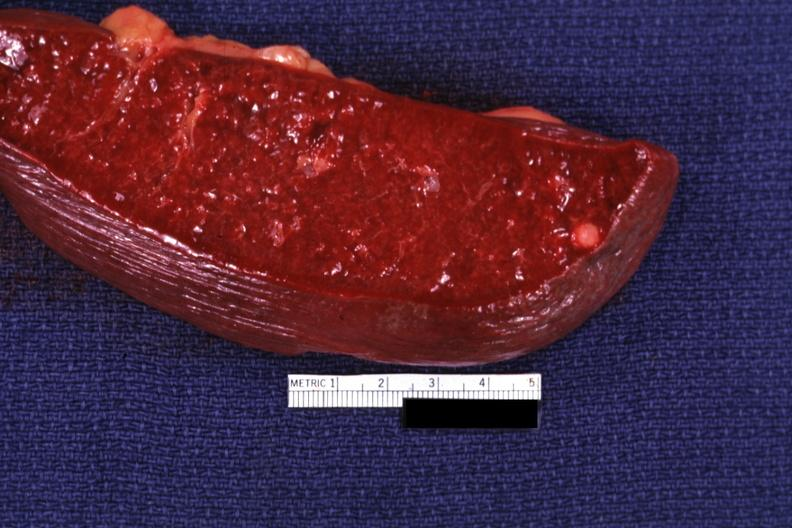what healed granuloma?
Answer the question using a single word or phrase. Cut surface with typical 